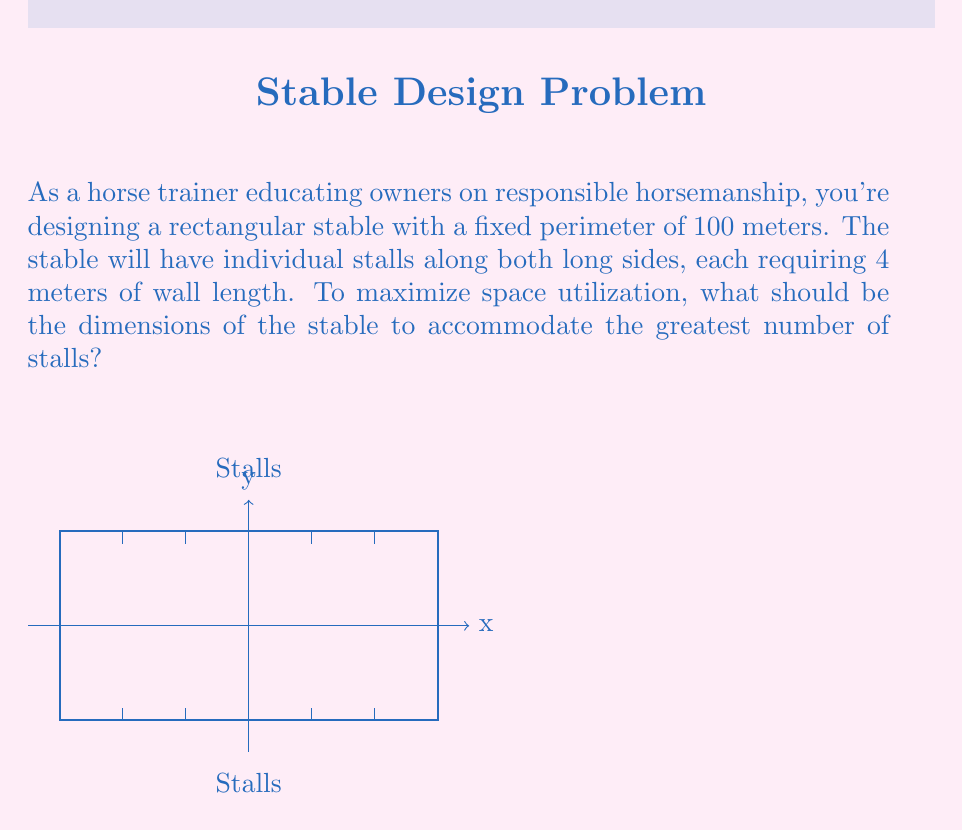Can you solve this math problem? Let's approach this step-by-step:

1) Let $x$ be the length and $y$ be the width of the stable.

2) Given the perimeter is 100 meters, we can write:
   $$2x + 2y = 100$$

3) Solving for $y$:
   $$y = 50 - x$$

4) The number of stalls on each long side is $\frac{x}{4}$ (as each stall requires 4 meters).

5) The total number of stalls $N$ is twice this:
   $$N = 2 \cdot \frac{x}{4} = \frac{x}{2}$$

6) Substituting $y$ from step 3:
   $$N = \frac{x}{2} = \frac{100 - 2y}{4}$$

7) To maximize $N$, we need to find the maximum of this function. We can do this by differentiating $N$ with respect to $x$ and setting it to zero:

   $$\frac{dN}{dx} = \frac{1}{2} - \frac{1}{2} \cdot \frac{dy}{dx} = 0$$

8) From step 2, we can derive $\frac{dy}{dx} = -\frac{1}{2}$

9) Substituting this into the equation from step 7:
   $$\frac{1}{2} - \frac{1}{2} \cdot (-\frac{1}{2}) = 0$$
   $$\frac{1}{2} + \frac{1}{4} = 0$$
   $$\frac{3}{4} = 0$$

10) This is always true, meaning $N$ is maximized when $x = y$.

11) Substituting this back into the perimeter equation:
    $$2x + 2x = 100$$
    $$4x = 100$$
    $$x = 25$$

12) Therefore, the optimal dimensions are 25m × 25m.

13) The number of stalls will be:
    $$N = \frac{x}{2} = \frac{25}{2} = 12.5$$

14) Since we can't have half a stall, we round down to 12 stalls in total.
Answer: 25m × 25m, accommodating 12 stalls 